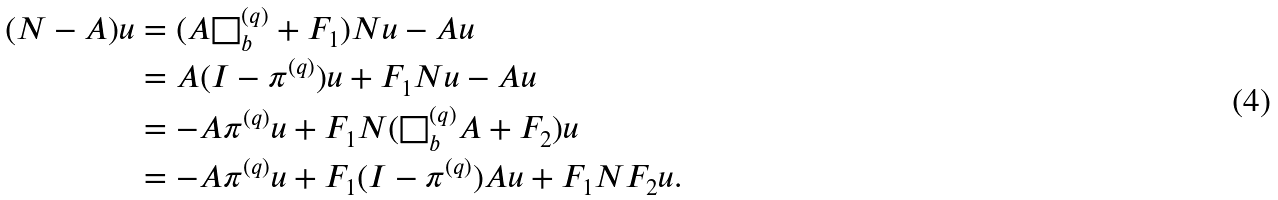<formula> <loc_0><loc_0><loc_500><loc_500>( N - A ) u & = ( A \Box ^ { ( q ) } _ { b } + F _ { 1 } ) N u - A u \\ & = A ( I - \pi ^ { ( q ) } ) u + F _ { 1 } N u - A u \\ & = - A \pi ^ { ( q ) } u + F _ { 1 } N ( \Box ^ { ( q ) } _ { b } A + F _ { 2 } ) u \\ & = - A \pi ^ { ( q ) } u + F _ { 1 } ( I - \pi ^ { ( q ) } ) A u + F _ { 1 } N F _ { 2 } u .</formula> 